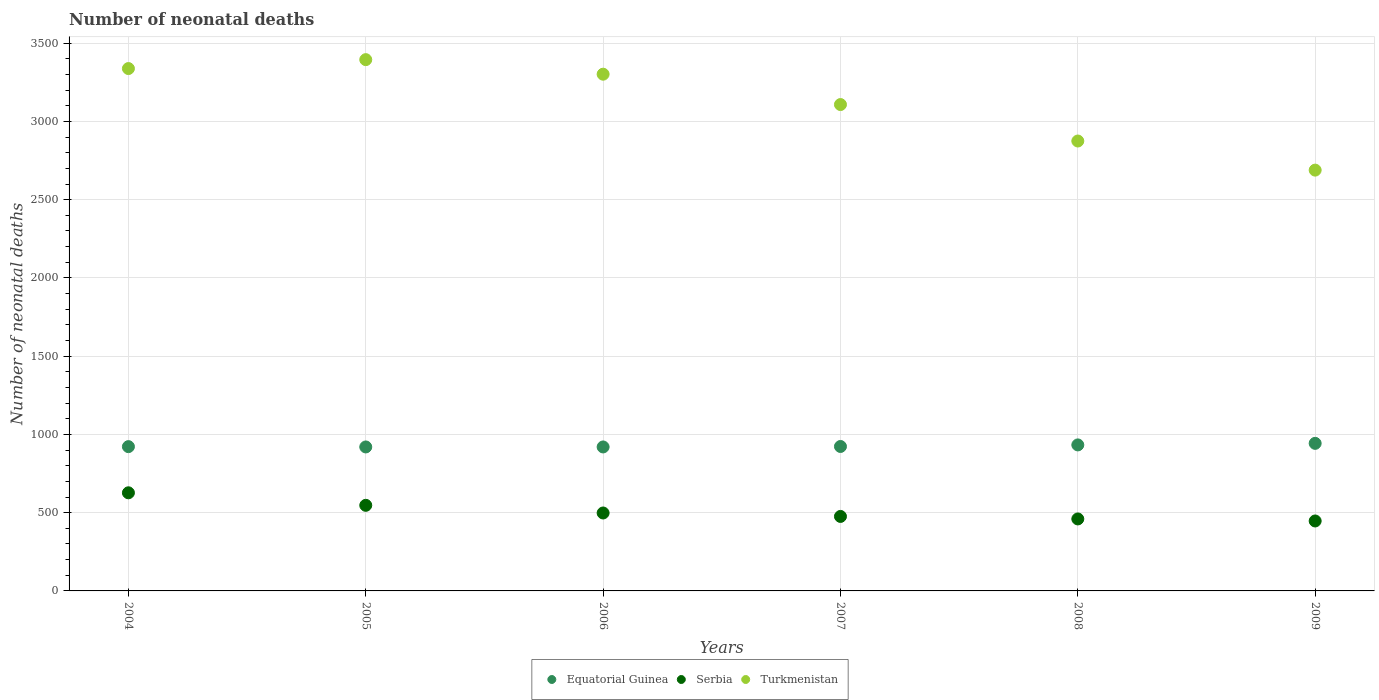How many different coloured dotlines are there?
Give a very brief answer. 3. What is the number of neonatal deaths in in Turkmenistan in 2004?
Keep it short and to the point. 3338. Across all years, what is the maximum number of neonatal deaths in in Turkmenistan?
Ensure brevity in your answer.  3395. Across all years, what is the minimum number of neonatal deaths in in Turkmenistan?
Make the answer very short. 2689. In which year was the number of neonatal deaths in in Serbia minimum?
Provide a short and direct response. 2009. What is the total number of neonatal deaths in in Serbia in the graph?
Your response must be concise. 3055. What is the difference between the number of neonatal deaths in in Turkmenistan in 2005 and that in 2009?
Your answer should be very brief. 706. What is the difference between the number of neonatal deaths in in Serbia in 2005 and the number of neonatal deaths in in Equatorial Guinea in 2007?
Make the answer very short. -376. What is the average number of neonatal deaths in in Serbia per year?
Offer a very short reply. 509.17. In the year 2004, what is the difference between the number of neonatal deaths in in Serbia and number of neonatal deaths in in Equatorial Guinea?
Keep it short and to the point. -295. In how many years, is the number of neonatal deaths in in Turkmenistan greater than 800?
Give a very brief answer. 6. What is the ratio of the number of neonatal deaths in in Serbia in 2005 to that in 2006?
Offer a terse response. 1.1. What is the difference between the highest and the second highest number of neonatal deaths in in Equatorial Guinea?
Provide a short and direct response. 10. What is the difference between the highest and the lowest number of neonatal deaths in in Serbia?
Your answer should be compact. 180. Is it the case that in every year, the sum of the number of neonatal deaths in in Turkmenistan and number of neonatal deaths in in Equatorial Guinea  is greater than the number of neonatal deaths in in Serbia?
Give a very brief answer. Yes. Does the number of neonatal deaths in in Serbia monotonically increase over the years?
Your answer should be compact. No. What is the difference between two consecutive major ticks on the Y-axis?
Make the answer very short. 500. Are the values on the major ticks of Y-axis written in scientific E-notation?
Keep it short and to the point. No. Does the graph contain any zero values?
Your answer should be very brief. No. Does the graph contain grids?
Make the answer very short. Yes. What is the title of the graph?
Offer a very short reply. Number of neonatal deaths. Does "Guam" appear as one of the legend labels in the graph?
Ensure brevity in your answer.  No. What is the label or title of the Y-axis?
Make the answer very short. Number of neonatal deaths. What is the Number of neonatal deaths of Equatorial Guinea in 2004?
Keep it short and to the point. 922. What is the Number of neonatal deaths of Serbia in 2004?
Make the answer very short. 627. What is the Number of neonatal deaths in Turkmenistan in 2004?
Give a very brief answer. 3338. What is the Number of neonatal deaths in Equatorial Guinea in 2005?
Offer a very short reply. 920. What is the Number of neonatal deaths in Serbia in 2005?
Provide a short and direct response. 547. What is the Number of neonatal deaths of Turkmenistan in 2005?
Make the answer very short. 3395. What is the Number of neonatal deaths of Equatorial Guinea in 2006?
Offer a terse response. 920. What is the Number of neonatal deaths of Serbia in 2006?
Ensure brevity in your answer.  498. What is the Number of neonatal deaths in Turkmenistan in 2006?
Offer a terse response. 3302. What is the Number of neonatal deaths of Equatorial Guinea in 2007?
Give a very brief answer. 923. What is the Number of neonatal deaths in Serbia in 2007?
Provide a succinct answer. 476. What is the Number of neonatal deaths of Turkmenistan in 2007?
Provide a succinct answer. 3108. What is the Number of neonatal deaths in Equatorial Guinea in 2008?
Your answer should be very brief. 933. What is the Number of neonatal deaths in Serbia in 2008?
Your response must be concise. 460. What is the Number of neonatal deaths of Turkmenistan in 2008?
Offer a very short reply. 2875. What is the Number of neonatal deaths in Equatorial Guinea in 2009?
Provide a succinct answer. 943. What is the Number of neonatal deaths of Serbia in 2009?
Offer a terse response. 447. What is the Number of neonatal deaths in Turkmenistan in 2009?
Provide a short and direct response. 2689. Across all years, what is the maximum Number of neonatal deaths of Equatorial Guinea?
Your answer should be very brief. 943. Across all years, what is the maximum Number of neonatal deaths of Serbia?
Offer a very short reply. 627. Across all years, what is the maximum Number of neonatal deaths of Turkmenistan?
Your response must be concise. 3395. Across all years, what is the minimum Number of neonatal deaths of Equatorial Guinea?
Ensure brevity in your answer.  920. Across all years, what is the minimum Number of neonatal deaths in Serbia?
Your response must be concise. 447. Across all years, what is the minimum Number of neonatal deaths of Turkmenistan?
Give a very brief answer. 2689. What is the total Number of neonatal deaths of Equatorial Guinea in the graph?
Give a very brief answer. 5561. What is the total Number of neonatal deaths in Serbia in the graph?
Your response must be concise. 3055. What is the total Number of neonatal deaths in Turkmenistan in the graph?
Your answer should be very brief. 1.87e+04. What is the difference between the Number of neonatal deaths of Equatorial Guinea in 2004 and that in 2005?
Ensure brevity in your answer.  2. What is the difference between the Number of neonatal deaths of Serbia in 2004 and that in 2005?
Your answer should be compact. 80. What is the difference between the Number of neonatal deaths of Turkmenistan in 2004 and that in 2005?
Keep it short and to the point. -57. What is the difference between the Number of neonatal deaths of Equatorial Guinea in 2004 and that in 2006?
Offer a terse response. 2. What is the difference between the Number of neonatal deaths of Serbia in 2004 and that in 2006?
Your response must be concise. 129. What is the difference between the Number of neonatal deaths of Turkmenistan in 2004 and that in 2006?
Make the answer very short. 36. What is the difference between the Number of neonatal deaths in Equatorial Guinea in 2004 and that in 2007?
Offer a terse response. -1. What is the difference between the Number of neonatal deaths of Serbia in 2004 and that in 2007?
Give a very brief answer. 151. What is the difference between the Number of neonatal deaths of Turkmenistan in 2004 and that in 2007?
Your answer should be very brief. 230. What is the difference between the Number of neonatal deaths of Serbia in 2004 and that in 2008?
Your response must be concise. 167. What is the difference between the Number of neonatal deaths of Turkmenistan in 2004 and that in 2008?
Provide a short and direct response. 463. What is the difference between the Number of neonatal deaths of Equatorial Guinea in 2004 and that in 2009?
Make the answer very short. -21. What is the difference between the Number of neonatal deaths of Serbia in 2004 and that in 2009?
Make the answer very short. 180. What is the difference between the Number of neonatal deaths of Turkmenistan in 2004 and that in 2009?
Your answer should be very brief. 649. What is the difference between the Number of neonatal deaths in Equatorial Guinea in 2005 and that in 2006?
Your answer should be compact. 0. What is the difference between the Number of neonatal deaths in Serbia in 2005 and that in 2006?
Your answer should be very brief. 49. What is the difference between the Number of neonatal deaths of Turkmenistan in 2005 and that in 2006?
Provide a short and direct response. 93. What is the difference between the Number of neonatal deaths in Equatorial Guinea in 2005 and that in 2007?
Ensure brevity in your answer.  -3. What is the difference between the Number of neonatal deaths of Turkmenistan in 2005 and that in 2007?
Your response must be concise. 287. What is the difference between the Number of neonatal deaths in Turkmenistan in 2005 and that in 2008?
Provide a short and direct response. 520. What is the difference between the Number of neonatal deaths of Equatorial Guinea in 2005 and that in 2009?
Your answer should be very brief. -23. What is the difference between the Number of neonatal deaths in Turkmenistan in 2005 and that in 2009?
Your answer should be compact. 706. What is the difference between the Number of neonatal deaths in Turkmenistan in 2006 and that in 2007?
Provide a succinct answer. 194. What is the difference between the Number of neonatal deaths in Equatorial Guinea in 2006 and that in 2008?
Your response must be concise. -13. What is the difference between the Number of neonatal deaths of Turkmenistan in 2006 and that in 2008?
Keep it short and to the point. 427. What is the difference between the Number of neonatal deaths of Equatorial Guinea in 2006 and that in 2009?
Your response must be concise. -23. What is the difference between the Number of neonatal deaths in Serbia in 2006 and that in 2009?
Provide a short and direct response. 51. What is the difference between the Number of neonatal deaths in Turkmenistan in 2006 and that in 2009?
Ensure brevity in your answer.  613. What is the difference between the Number of neonatal deaths in Equatorial Guinea in 2007 and that in 2008?
Provide a short and direct response. -10. What is the difference between the Number of neonatal deaths in Serbia in 2007 and that in 2008?
Ensure brevity in your answer.  16. What is the difference between the Number of neonatal deaths in Turkmenistan in 2007 and that in 2008?
Your answer should be compact. 233. What is the difference between the Number of neonatal deaths in Serbia in 2007 and that in 2009?
Your answer should be compact. 29. What is the difference between the Number of neonatal deaths in Turkmenistan in 2007 and that in 2009?
Offer a very short reply. 419. What is the difference between the Number of neonatal deaths of Serbia in 2008 and that in 2009?
Make the answer very short. 13. What is the difference between the Number of neonatal deaths in Turkmenistan in 2008 and that in 2009?
Ensure brevity in your answer.  186. What is the difference between the Number of neonatal deaths in Equatorial Guinea in 2004 and the Number of neonatal deaths in Serbia in 2005?
Offer a very short reply. 375. What is the difference between the Number of neonatal deaths of Equatorial Guinea in 2004 and the Number of neonatal deaths of Turkmenistan in 2005?
Provide a succinct answer. -2473. What is the difference between the Number of neonatal deaths in Serbia in 2004 and the Number of neonatal deaths in Turkmenistan in 2005?
Your response must be concise. -2768. What is the difference between the Number of neonatal deaths in Equatorial Guinea in 2004 and the Number of neonatal deaths in Serbia in 2006?
Your answer should be compact. 424. What is the difference between the Number of neonatal deaths of Equatorial Guinea in 2004 and the Number of neonatal deaths of Turkmenistan in 2006?
Ensure brevity in your answer.  -2380. What is the difference between the Number of neonatal deaths of Serbia in 2004 and the Number of neonatal deaths of Turkmenistan in 2006?
Provide a short and direct response. -2675. What is the difference between the Number of neonatal deaths in Equatorial Guinea in 2004 and the Number of neonatal deaths in Serbia in 2007?
Keep it short and to the point. 446. What is the difference between the Number of neonatal deaths of Equatorial Guinea in 2004 and the Number of neonatal deaths of Turkmenistan in 2007?
Ensure brevity in your answer.  -2186. What is the difference between the Number of neonatal deaths in Serbia in 2004 and the Number of neonatal deaths in Turkmenistan in 2007?
Make the answer very short. -2481. What is the difference between the Number of neonatal deaths of Equatorial Guinea in 2004 and the Number of neonatal deaths of Serbia in 2008?
Provide a succinct answer. 462. What is the difference between the Number of neonatal deaths of Equatorial Guinea in 2004 and the Number of neonatal deaths of Turkmenistan in 2008?
Your response must be concise. -1953. What is the difference between the Number of neonatal deaths in Serbia in 2004 and the Number of neonatal deaths in Turkmenistan in 2008?
Your response must be concise. -2248. What is the difference between the Number of neonatal deaths in Equatorial Guinea in 2004 and the Number of neonatal deaths in Serbia in 2009?
Give a very brief answer. 475. What is the difference between the Number of neonatal deaths in Equatorial Guinea in 2004 and the Number of neonatal deaths in Turkmenistan in 2009?
Keep it short and to the point. -1767. What is the difference between the Number of neonatal deaths of Serbia in 2004 and the Number of neonatal deaths of Turkmenistan in 2009?
Keep it short and to the point. -2062. What is the difference between the Number of neonatal deaths in Equatorial Guinea in 2005 and the Number of neonatal deaths in Serbia in 2006?
Your response must be concise. 422. What is the difference between the Number of neonatal deaths of Equatorial Guinea in 2005 and the Number of neonatal deaths of Turkmenistan in 2006?
Give a very brief answer. -2382. What is the difference between the Number of neonatal deaths in Serbia in 2005 and the Number of neonatal deaths in Turkmenistan in 2006?
Provide a succinct answer. -2755. What is the difference between the Number of neonatal deaths in Equatorial Guinea in 2005 and the Number of neonatal deaths in Serbia in 2007?
Ensure brevity in your answer.  444. What is the difference between the Number of neonatal deaths in Equatorial Guinea in 2005 and the Number of neonatal deaths in Turkmenistan in 2007?
Your answer should be very brief. -2188. What is the difference between the Number of neonatal deaths of Serbia in 2005 and the Number of neonatal deaths of Turkmenistan in 2007?
Your answer should be very brief. -2561. What is the difference between the Number of neonatal deaths in Equatorial Guinea in 2005 and the Number of neonatal deaths in Serbia in 2008?
Give a very brief answer. 460. What is the difference between the Number of neonatal deaths of Equatorial Guinea in 2005 and the Number of neonatal deaths of Turkmenistan in 2008?
Offer a terse response. -1955. What is the difference between the Number of neonatal deaths in Serbia in 2005 and the Number of neonatal deaths in Turkmenistan in 2008?
Provide a succinct answer. -2328. What is the difference between the Number of neonatal deaths in Equatorial Guinea in 2005 and the Number of neonatal deaths in Serbia in 2009?
Your answer should be compact. 473. What is the difference between the Number of neonatal deaths in Equatorial Guinea in 2005 and the Number of neonatal deaths in Turkmenistan in 2009?
Give a very brief answer. -1769. What is the difference between the Number of neonatal deaths of Serbia in 2005 and the Number of neonatal deaths of Turkmenistan in 2009?
Ensure brevity in your answer.  -2142. What is the difference between the Number of neonatal deaths in Equatorial Guinea in 2006 and the Number of neonatal deaths in Serbia in 2007?
Give a very brief answer. 444. What is the difference between the Number of neonatal deaths in Equatorial Guinea in 2006 and the Number of neonatal deaths in Turkmenistan in 2007?
Make the answer very short. -2188. What is the difference between the Number of neonatal deaths in Serbia in 2006 and the Number of neonatal deaths in Turkmenistan in 2007?
Offer a terse response. -2610. What is the difference between the Number of neonatal deaths of Equatorial Guinea in 2006 and the Number of neonatal deaths of Serbia in 2008?
Provide a short and direct response. 460. What is the difference between the Number of neonatal deaths in Equatorial Guinea in 2006 and the Number of neonatal deaths in Turkmenistan in 2008?
Offer a terse response. -1955. What is the difference between the Number of neonatal deaths of Serbia in 2006 and the Number of neonatal deaths of Turkmenistan in 2008?
Your answer should be very brief. -2377. What is the difference between the Number of neonatal deaths in Equatorial Guinea in 2006 and the Number of neonatal deaths in Serbia in 2009?
Your answer should be very brief. 473. What is the difference between the Number of neonatal deaths in Equatorial Guinea in 2006 and the Number of neonatal deaths in Turkmenistan in 2009?
Provide a short and direct response. -1769. What is the difference between the Number of neonatal deaths in Serbia in 2006 and the Number of neonatal deaths in Turkmenistan in 2009?
Provide a succinct answer. -2191. What is the difference between the Number of neonatal deaths in Equatorial Guinea in 2007 and the Number of neonatal deaths in Serbia in 2008?
Ensure brevity in your answer.  463. What is the difference between the Number of neonatal deaths of Equatorial Guinea in 2007 and the Number of neonatal deaths of Turkmenistan in 2008?
Ensure brevity in your answer.  -1952. What is the difference between the Number of neonatal deaths of Serbia in 2007 and the Number of neonatal deaths of Turkmenistan in 2008?
Offer a very short reply. -2399. What is the difference between the Number of neonatal deaths of Equatorial Guinea in 2007 and the Number of neonatal deaths of Serbia in 2009?
Your response must be concise. 476. What is the difference between the Number of neonatal deaths of Equatorial Guinea in 2007 and the Number of neonatal deaths of Turkmenistan in 2009?
Offer a very short reply. -1766. What is the difference between the Number of neonatal deaths in Serbia in 2007 and the Number of neonatal deaths in Turkmenistan in 2009?
Provide a short and direct response. -2213. What is the difference between the Number of neonatal deaths of Equatorial Guinea in 2008 and the Number of neonatal deaths of Serbia in 2009?
Give a very brief answer. 486. What is the difference between the Number of neonatal deaths of Equatorial Guinea in 2008 and the Number of neonatal deaths of Turkmenistan in 2009?
Provide a short and direct response. -1756. What is the difference between the Number of neonatal deaths of Serbia in 2008 and the Number of neonatal deaths of Turkmenistan in 2009?
Provide a succinct answer. -2229. What is the average Number of neonatal deaths in Equatorial Guinea per year?
Make the answer very short. 926.83. What is the average Number of neonatal deaths of Serbia per year?
Offer a terse response. 509.17. What is the average Number of neonatal deaths in Turkmenistan per year?
Make the answer very short. 3117.83. In the year 2004, what is the difference between the Number of neonatal deaths of Equatorial Guinea and Number of neonatal deaths of Serbia?
Ensure brevity in your answer.  295. In the year 2004, what is the difference between the Number of neonatal deaths in Equatorial Guinea and Number of neonatal deaths in Turkmenistan?
Ensure brevity in your answer.  -2416. In the year 2004, what is the difference between the Number of neonatal deaths of Serbia and Number of neonatal deaths of Turkmenistan?
Ensure brevity in your answer.  -2711. In the year 2005, what is the difference between the Number of neonatal deaths of Equatorial Guinea and Number of neonatal deaths of Serbia?
Provide a succinct answer. 373. In the year 2005, what is the difference between the Number of neonatal deaths in Equatorial Guinea and Number of neonatal deaths in Turkmenistan?
Give a very brief answer. -2475. In the year 2005, what is the difference between the Number of neonatal deaths of Serbia and Number of neonatal deaths of Turkmenistan?
Ensure brevity in your answer.  -2848. In the year 2006, what is the difference between the Number of neonatal deaths of Equatorial Guinea and Number of neonatal deaths of Serbia?
Provide a succinct answer. 422. In the year 2006, what is the difference between the Number of neonatal deaths in Equatorial Guinea and Number of neonatal deaths in Turkmenistan?
Give a very brief answer. -2382. In the year 2006, what is the difference between the Number of neonatal deaths of Serbia and Number of neonatal deaths of Turkmenistan?
Offer a very short reply. -2804. In the year 2007, what is the difference between the Number of neonatal deaths in Equatorial Guinea and Number of neonatal deaths in Serbia?
Give a very brief answer. 447. In the year 2007, what is the difference between the Number of neonatal deaths of Equatorial Guinea and Number of neonatal deaths of Turkmenistan?
Make the answer very short. -2185. In the year 2007, what is the difference between the Number of neonatal deaths of Serbia and Number of neonatal deaths of Turkmenistan?
Offer a terse response. -2632. In the year 2008, what is the difference between the Number of neonatal deaths in Equatorial Guinea and Number of neonatal deaths in Serbia?
Ensure brevity in your answer.  473. In the year 2008, what is the difference between the Number of neonatal deaths in Equatorial Guinea and Number of neonatal deaths in Turkmenistan?
Keep it short and to the point. -1942. In the year 2008, what is the difference between the Number of neonatal deaths of Serbia and Number of neonatal deaths of Turkmenistan?
Your response must be concise. -2415. In the year 2009, what is the difference between the Number of neonatal deaths in Equatorial Guinea and Number of neonatal deaths in Serbia?
Your answer should be compact. 496. In the year 2009, what is the difference between the Number of neonatal deaths in Equatorial Guinea and Number of neonatal deaths in Turkmenistan?
Give a very brief answer. -1746. In the year 2009, what is the difference between the Number of neonatal deaths in Serbia and Number of neonatal deaths in Turkmenistan?
Make the answer very short. -2242. What is the ratio of the Number of neonatal deaths of Serbia in 2004 to that in 2005?
Your response must be concise. 1.15. What is the ratio of the Number of neonatal deaths in Turkmenistan in 2004 to that in 2005?
Your answer should be very brief. 0.98. What is the ratio of the Number of neonatal deaths of Equatorial Guinea in 2004 to that in 2006?
Provide a short and direct response. 1. What is the ratio of the Number of neonatal deaths in Serbia in 2004 to that in 2006?
Provide a short and direct response. 1.26. What is the ratio of the Number of neonatal deaths of Turkmenistan in 2004 to that in 2006?
Provide a short and direct response. 1.01. What is the ratio of the Number of neonatal deaths of Serbia in 2004 to that in 2007?
Offer a very short reply. 1.32. What is the ratio of the Number of neonatal deaths of Turkmenistan in 2004 to that in 2007?
Provide a succinct answer. 1.07. What is the ratio of the Number of neonatal deaths in Equatorial Guinea in 2004 to that in 2008?
Provide a short and direct response. 0.99. What is the ratio of the Number of neonatal deaths in Serbia in 2004 to that in 2008?
Provide a short and direct response. 1.36. What is the ratio of the Number of neonatal deaths of Turkmenistan in 2004 to that in 2008?
Make the answer very short. 1.16. What is the ratio of the Number of neonatal deaths of Equatorial Guinea in 2004 to that in 2009?
Ensure brevity in your answer.  0.98. What is the ratio of the Number of neonatal deaths in Serbia in 2004 to that in 2009?
Your response must be concise. 1.4. What is the ratio of the Number of neonatal deaths in Turkmenistan in 2004 to that in 2009?
Ensure brevity in your answer.  1.24. What is the ratio of the Number of neonatal deaths in Serbia in 2005 to that in 2006?
Your answer should be compact. 1.1. What is the ratio of the Number of neonatal deaths of Turkmenistan in 2005 to that in 2006?
Offer a very short reply. 1.03. What is the ratio of the Number of neonatal deaths of Equatorial Guinea in 2005 to that in 2007?
Provide a succinct answer. 1. What is the ratio of the Number of neonatal deaths of Serbia in 2005 to that in 2007?
Your response must be concise. 1.15. What is the ratio of the Number of neonatal deaths of Turkmenistan in 2005 to that in 2007?
Offer a terse response. 1.09. What is the ratio of the Number of neonatal deaths of Equatorial Guinea in 2005 to that in 2008?
Your response must be concise. 0.99. What is the ratio of the Number of neonatal deaths in Serbia in 2005 to that in 2008?
Your response must be concise. 1.19. What is the ratio of the Number of neonatal deaths of Turkmenistan in 2005 to that in 2008?
Your response must be concise. 1.18. What is the ratio of the Number of neonatal deaths of Equatorial Guinea in 2005 to that in 2009?
Offer a very short reply. 0.98. What is the ratio of the Number of neonatal deaths of Serbia in 2005 to that in 2009?
Your answer should be very brief. 1.22. What is the ratio of the Number of neonatal deaths of Turkmenistan in 2005 to that in 2009?
Make the answer very short. 1.26. What is the ratio of the Number of neonatal deaths of Serbia in 2006 to that in 2007?
Your answer should be compact. 1.05. What is the ratio of the Number of neonatal deaths of Turkmenistan in 2006 to that in 2007?
Your answer should be very brief. 1.06. What is the ratio of the Number of neonatal deaths of Equatorial Guinea in 2006 to that in 2008?
Your response must be concise. 0.99. What is the ratio of the Number of neonatal deaths of Serbia in 2006 to that in 2008?
Provide a succinct answer. 1.08. What is the ratio of the Number of neonatal deaths of Turkmenistan in 2006 to that in 2008?
Your response must be concise. 1.15. What is the ratio of the Number of neonatal deaths in Equatorial Guinea in 2006 to that in 2009?
Make the answer very short. 0.98. What is the ratio of the Number of neonatal deaths of Serbia in 2006 to that in 2009?
Provide a short and direct response. 1.11. What is the ratio of the Number of neonatal deaths of Turkmenistan in 2006 to that in 2009?
Offer a very short reply. 1.23. What is the ratio of the Number of neonatal deaths in Equatorial Guinea in 2007 to that in 2008?
Offer a terse response. 0.99. What is the ratio of the Number of neonatal deaths of Serbia in 2007 to that in 2008?
Your answer should be compact. 1.03. What is the ratio of the Number of neonatal deaths in Turkmenistan in 2007 to that in 2008?
Provide a succinct answer. 1.08. What is the ratio of the Number of neonatal deaths of Equatorial Guinea in 2007 to that in 2009?
Ensure brevity in your answer.  0.98. What is the ratio of the Number of neonatal deaths of Serbia in 2007 to that in 2009?
Provide a succinct answer. 1.06. What is the ratio of the Number of neonatal deaths of Turkmenistan in 2007 to that in 2009?
Keep it short and to the point. 1.16. What is the ratio of the Number of neonatal deaths in Serbia in 2008 to that in 2009?
Offer a terse response. 1.03. What is the ratio of the Number of neonatal deaths in Turkmenistan in 2008 to that in 2009?
Your answer should be compact. 1.07. What is the difference between the highest and the second highest Number of neonatal deaths in Equatorial Guinea?
Your response must be concise. 10. What is the difference between the highest and the second highest Number of neonatal deaths in Serbia?
Offer a very short reply. 80. What is the difference between the highest and the lowest Number of neonatal deaths of Equatorial Guinea?
Offer a terse response. 23. What is the difference between the highest and the lowest Number of neonatal deaths in Serbia?
Keep it short and to the point. 180. What is the difference between the highest and the lowest Number of neonatal deaths of Turkmenistan?
Give a very brief answer. 706. 